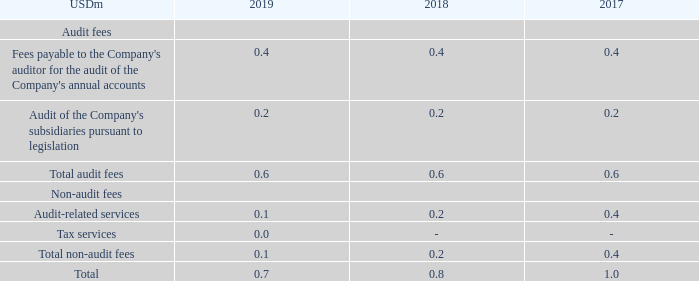NOTE 4 – REMUNERATION TO AUDITORS APPOINTED AT THE PARENT COMPANY’S ANNUAL GENERAL MEETING
Under SEC regulations, the remuneration of the auditor of USD 0.7m (2018: USD 0.8m, 2017: USD 1.0m) is required to be presented as follows: Audit USD 0.6m (2018: USD 0.6m, 2017: USD 0.6m) and other audit-related services USD 0.1m (2018: USD 0.2m, 2017: USD 0.4m).
Our Audit Committee pre-approves all audit, audit-related and non-audit services not prohibited by law to be performed by our independent auditors and associated fees prior to the engagement of the independent auditor with respect to such services.
What was the remuneration to the auditor in 2019? Usd 0.7m. What was the amount of total audit fees in 2019? Usd 0.6m. What are the types of audit fees in the table? Fees payable to the company's auditor for the audit of the company's annual accounts, audit of the company's subsidiaries pursuant to legislation. In which year was the total remuneration to the auditor the largest? 1.0>0.8>0.7
Answer: 2017. What was the change in the the total remuneration to the auditor in 2019 from 2018?
Answer scale should be: million. 0.7-0.8
Answer: -0.1. What was the percentage change in the the total remuneration to the auditor in 2019 from 2018?
Answer scale should be: percent. (0.7-0.8)/0.8
Answer: -12.5. 